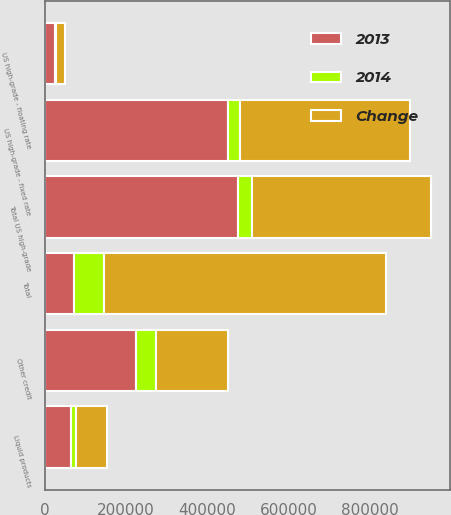<chart> <loc_0><loc_0><loc_500><loc_500><stacked_bar_chart><ecel><fcel>US high-grade - fixed rate<fcel>US high-grade - floating rate<fcel>Total US high-grade<fcel>Other credit<fcel>Liquid products<fcel>Total<nl><fcel>2013<fcel>450139<fcel>25231<fcel>475370<fcel>226033<fcel>65558<fcel>73285<nl><fcel>Change<fcel>418270<fcel>21813<fcel>440083<fcel>177274<fcel>76319<fcel>693676<nl><fcel>2014<fcel>31869<fcel>3418<fcel>35287<fcel>48759<fcel>10761<fcel>73285<nl></chart> 